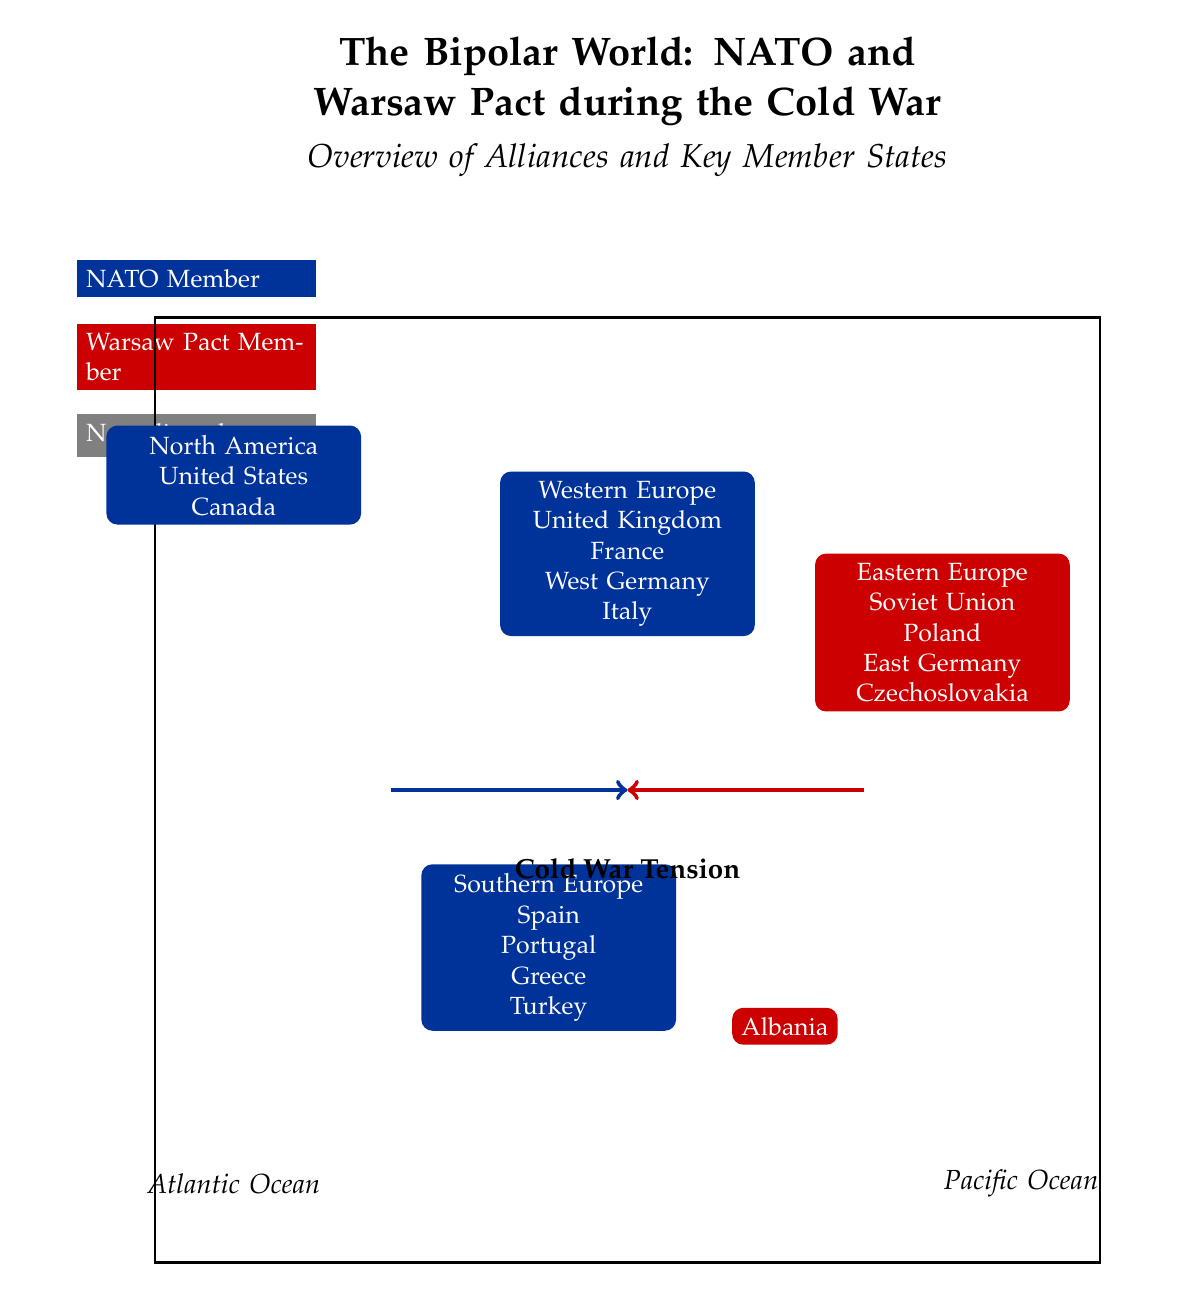What do the blue regions on the map represent? The blue regions on the map are labeled as NATO Member states, indicated by the blue color. According to the diagram, these regions include North America and parts of Western and Southern Europe, specifically countries like the United States, Canada, the United Kingdom, France, West Germany, Italy, Spain, Portugal, Greece, and Turkey.
Answer: NATO Member How many countries are listed under Eastern Europe? The Eastern Europe section of the diagram identifies four countries: the Soviet Union, Poland, East Germany, and Czechoslovakia, which are represented in the red region indicating Warsaw Pact members. This count of four is derived directly from the information shown in that area of the diagram.
Answer: 4 Which two alliances are shown in the diagram? The diagram specifically illustrates two alliances during the Cold War: NATO, represented by the blue color, and the Warsaw Pact, represented by the red color. By checking the legend, one can identify these alliances under their respective colors.
Answer: NATO and Warsaw Pact What country is listed uniquely among the Southern European nations? The diagram distinguishes Albania within the Southern Europe region, marked in red, as it is a Warsaw Pact member, while the others listed, such as Spain, Portugal, Greece, and Turkey, are NATO members. This highlights Albania's unique position within Southern Europe relative to the other nations displayed.
Answer: Albania What is illustrated between the NATO and Warsaw Pact alliances? The diagram illustrates Cold War Tension with a thick arrow pointing between the blue (NATO) and red (Warsaw Pact) regions, indicating conflict and opposition during that period. Notably, the arrow's label provides clarity on its significance.
Answer: Cold War Tension 